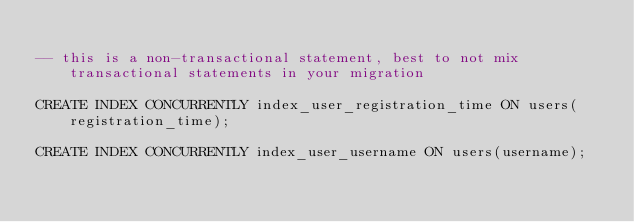<code> <loc_0><loc_0><loc_500><loc_500><_SQL_>
-- this is a non-transactional statement, best to not mix transactional statements in your migration

CREATE INDEX CONCURRENTLY index_user_registration_time ON users(registration_time);

CREATE INDEX CONCURRENTLY index_user_username ON users(username);
</code> 